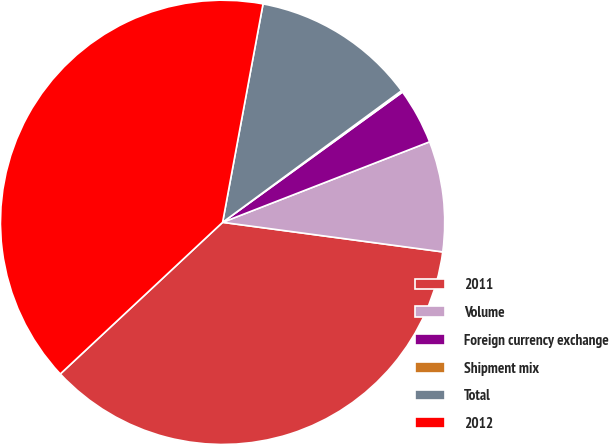Convert chart to OTSL. <chart><loc_0><loc_0><loc_500><loc_500><pie_chart><fcel>2011<fcel>Volume<fcel>Foreign currency exchange<fcel>Shipment mix<fcel>Total<fcel>2012<nl><fcel>35.91%<fcel>8.03%<fcel>4.07%<fcel>0.12%<fcel>11.99%<fcel>39.87%<nl></chart> 